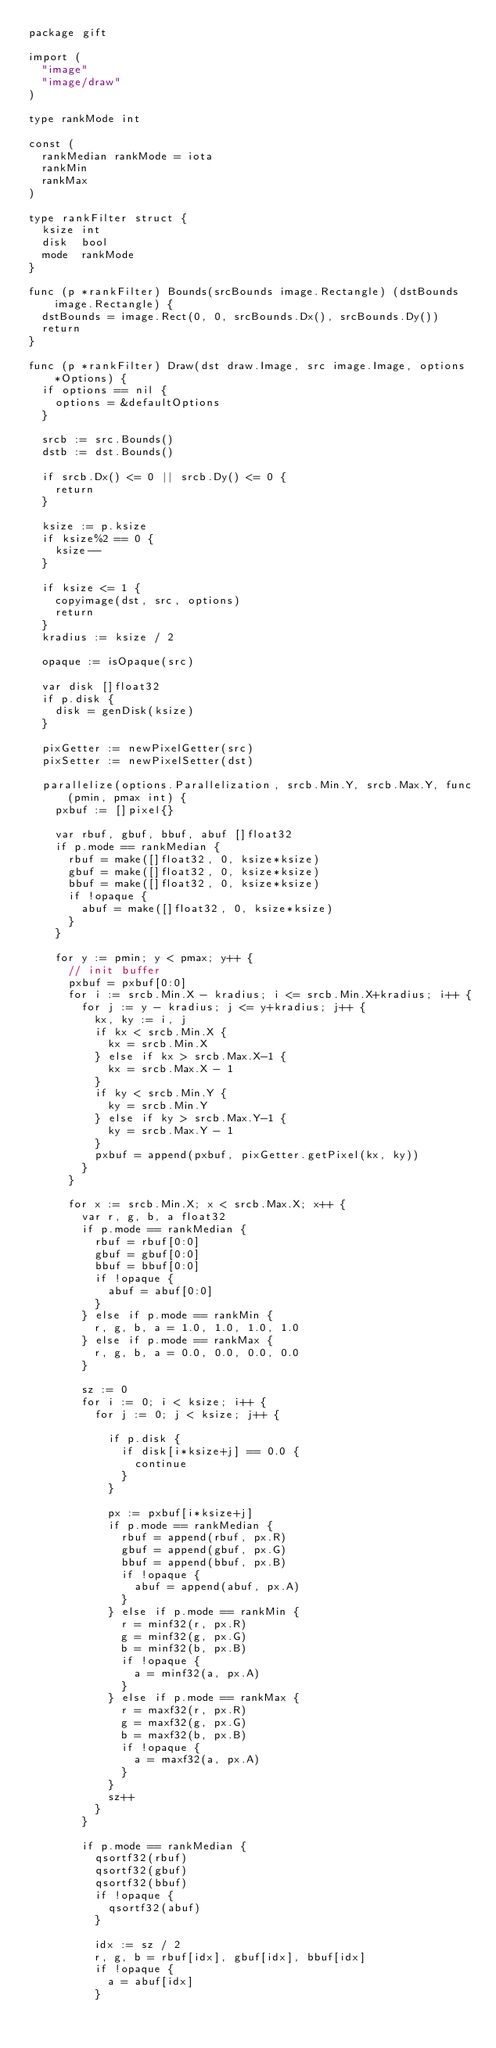Convert code to text. <code><loc_0><loc_0><loc_500><loc_500><_Go_>package gift

import (
	"image"
	"image/draw"
)

type rankMode int

const (
	rankMedian rankMode = iota
	rankMin
	rankMax
)

type rankFilter struct {
	ksize int
	disk  bool
	mode  rankMode
}

func (p *rankFilter) Bounds(srcBounds image.Rectangle) (dstBounds image.Rectangle) {
	dstBounds = image.Rect(0, 0, srcBounds.Dx(), srcBounds.Dy())
	return
}

func (p *rankFilter) Draw(dst draw.Image, src image.Image, options *Options) {
	if options == nil {
		options = &defaultOptions
	}

	srcb := src.Bounds()
	dstb := dst.Bounds()

	if srcb.Dx() <= 0 || srcb.Dy() <= 0 {
		return
	}

	ksize := p.ksize
	if ksize%2 == 0 {
		ksize--
	}

	if ksize <= 1 {
		copyimage(dst, src, options)
		return
	}
	kradius := ksize / 2

	opaque := isOpaque(src)

	var disk []float32
	if p.disk {
		disk = genDisk(ksize)
	}

	pixGetter := newPixelGetter(src)
	pixSetter := newPixelSetter(dst)

	parallelize(options.Parallelization, srcb.Min.Y, srcb.Max.Y, func(pmin, pmax int) {
		pxbuf := []pixel{}

		var rbuf, gbuf, bbuf, abuf []float32
		if p.mode == rankMedian {
			rbuf = make([]float32, 0, ksize*ksize)
			gbuf = make([]float32, 0, ksize*ksize)
			bbuf = make([]float32, 0, ksize*ksize)
			if !opaque {
				abuf = make([]float32, 0, ksize*ksize)
			}
		}

		for y := pmin; y < pmax; y++ {
			// init buffer
			pxbuf = pxbuf[0:0]
			for i := srcb.Min.X - kradius; i <= srcb.Min.X+kradius; i++ {
				for j := y - kradius; j <= y+kradius; j++ {
					kx, ky := i, j
					if kx < srcb.Min.X {
						kx = srcb.Min.X
					} else if kx > srcb.Max.X-1 {
						kx = srcb.Max.X - 1
					}
					if ky < srcb.Min.Y {
						ky = srcb.Min.Y
					} else if ky > srcb.Max.Y-1 {
						ky = srcb.Max.Y - 1
					}
					pxbuf = append(pxbuf, pixGetter.getPixel(kx, ky))
				}
			}

			for x := srcb.Min.X; x < srcb.Max.X; x++ {
				var r, g, b, a float32
				if p.mode == rankMedian {
					rbuf = rbuf[0:0]
					gbuf = gbuf[0:0]
					bbuf = bbuf[0:0]
					if !opaque {
						abuf = abuf[0:0]
					}
				} else if p.mode == rankMin {
					r, g, b, a = 1.0, 1.0, 1.0, 1.0
				} else if p.mode == rankMax {
					r, g, b, a = 0.0, 0.0, 0.0, 0.0
				}

				sz := 0
				for i := 0; i < ksize; i++ {
					for j := 0; j < ksize; j++ {

						if p.disk {
							if disk[i*ksize+j] == 0.0 {
								continue
							}
						}

						px := pxbuf[i*ksize+j]
						if p.mode == rankMedian {
							rbuf = append(rbuf, px.R)
							gbuf = append(gbuf, px.G)
							bbuf = append(bbuf, px.B)
							if !opaque {
								abuf = append(abuf, px.A)
							}
						} else if p.mode == rankMin {
							r = minf32(r, px.R)
							g = minf32(g, px.G)
							b = minf32(b, px.B)
							if !opaque {
								a = minf32(a, px.A)
							}
						} else if p.mode == rankMax {
							r = maxf32(r, px.R)
							g = maxf32(g, px.G)
							b = maxf32(b, px.B)
							if !opaque {
								a = maxf32(a, px.A)
							}
						}
						sz++
					}
				}

				if p.mode == rankMedian {
					qsortf32(rbuf)
					qsortf32(gbuf)
					qsortf32(bbuf)
					if !opaque {
						qsortf32(abuf)
					}

					idx := sz / 2
					r, g, b = rbuf[idx], gbuf[idx], bbuf[idx]
					if !opaque {
						a = abuf[idx]
					}</code> 